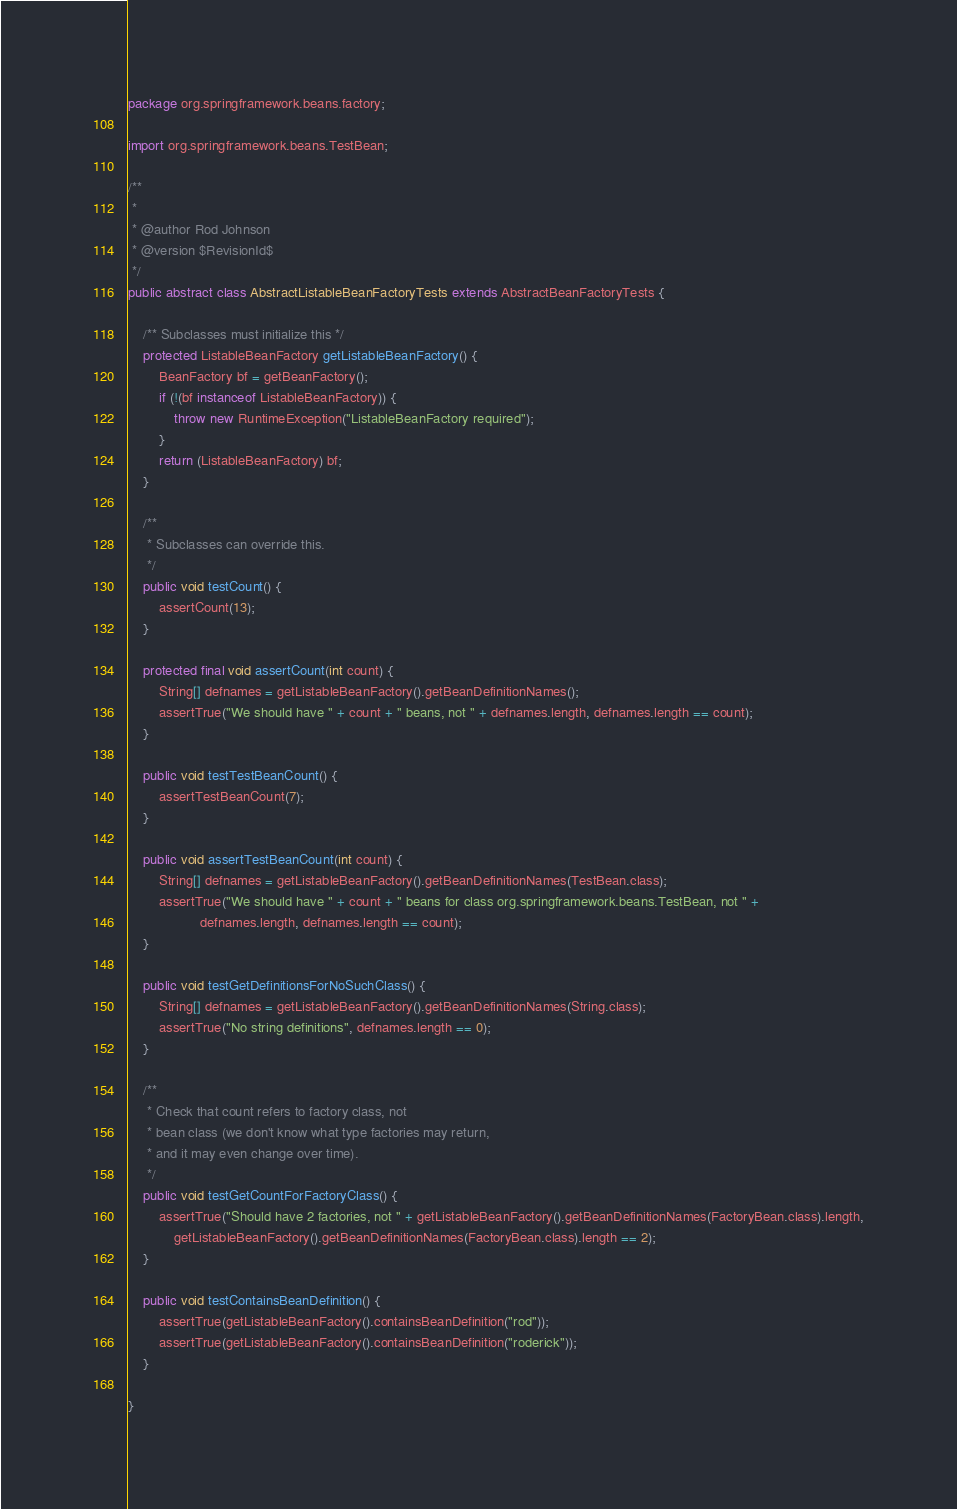Convert code to text. <code><loc_0><loc_0><loc_500><loc_500><_Java_>package org.springframework.beans.factory;

import org.springframework.beans.TestBean;

/**
 *
 * @author Rod Johnson
 * @version $RevisionId$
 */
public abstract class AbstractListableBeanFactoryTests extends AbstractBeanFactoryTests {

	/** Subclasses must initialize this */
	protected ListableBeanFactory getListableBeanFactory() {
		BeanFactory bf = getBeanFactory();
		if (!(bf instanceof ListableBeanFactory)) {
			throw new RuntimeException("ListableBeanFactory required");
		}
		return (ListableBeanFactory) bf;
	}
	
	/**
	 * Subclasses can override this.
	 */
	public void testCount() {
		assertCount(13);
	}
	
	protected final void assertCount(int count) {
		String[] defnames = getListableBeanFactory().getBeanDefinitionNames();
		assertTrue("We should have " + count + " beans, not " + defnames.length, defnames.length == count);
	}

	public void testTestBeanCount() {
		assertTestBeanCount(7);
	}

	public void assertTestBeanCount(int count) {
		String[] defnames = getListableBeanFactory().getBeanDefinitionNames(TestBean.class);
		assertTrue("We should have " + count + " beans for class org.springframework.beans.TestBean, not " +
		           defnames.length, defnames.length == count);
	}

	public void testGetDefinitionsForNoSuchClass() {
		String[] defnames = getListableBeanFactory().getBeanDefinitionNames(String.class);
		assertTrue("No string definitions", defnames.length == 0);
	}
	
	/**
	 * Check that count refers to factory class, not
	 * bean class (we don't know what type factories may return,
	 * and it may even change over time).
	 */
	public void testGetCountForFactoryClass() {
		assertTrue("Should have 2 factories, not " + getListableBeanFactory().getBeanDefinitionNames(FactoryBean.class).length,
			getListableBeanFactory().getBeanDefinitionNames(FactoryBean.class).length == 2);
	}

	public void testContainsBeanDefinition() {
		assertTrue(getListableBeanFactory().containsBeanDefinition("rod"));
		assertTrue(getListableBeanFactory().containsBeanDefinition("roderick"));
	}

}
</code> 